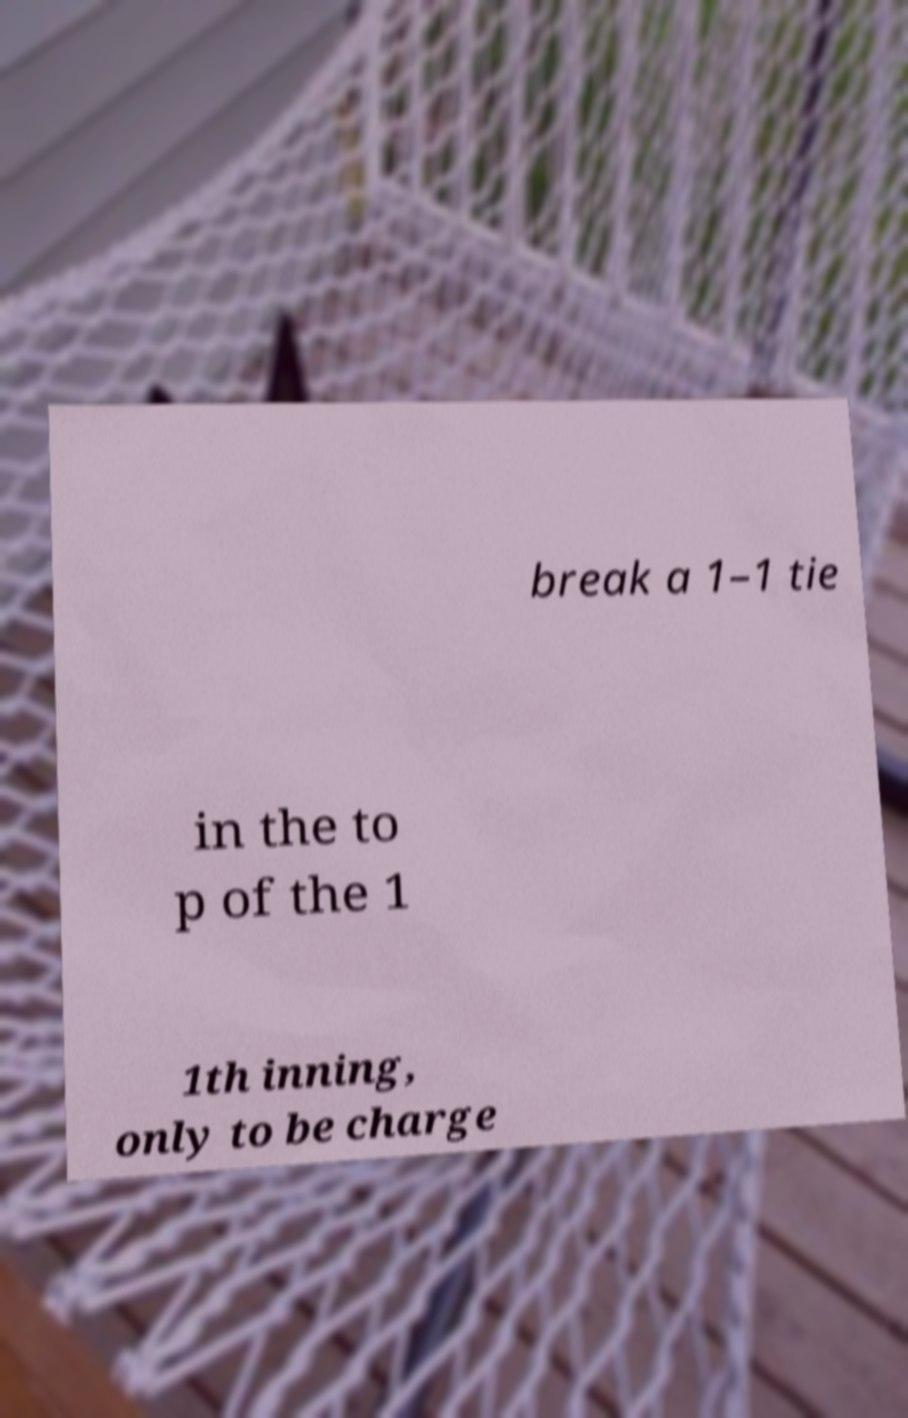Can you read and provide the text displayed in the image?This photo seems to have some interesting text. Can you extract and type it out for me? break a 1–1 tie in the to p of the 1 1th inning, only to be charge 